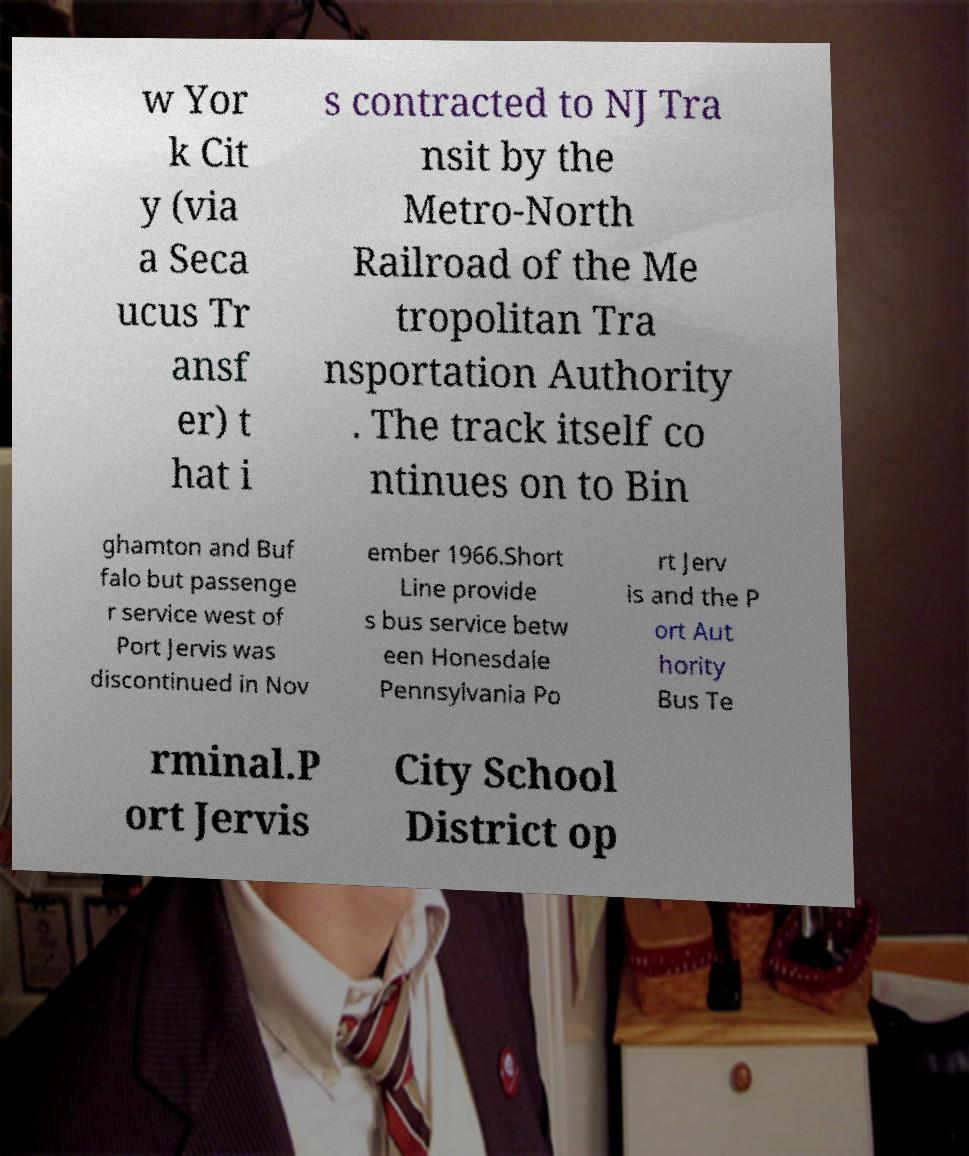Can you accurately transcribe the text from the provided image for me? w Yor k Cit y (via a Seca ucus Tr ansf er) t hat i s contracted to NJ Tra nsit by the Metro-North Railroad of the Me tropolitan Tra nsportation Authority . The track itself co ntinues on to Bin ghamton and Buf falo but passenge r service west of Port Jervis was discontinued in Nov ember 1966.Short Line provide s bus service betw een Honesdale Pennsylvania Po rt Jerv is and the P ort Aut hority Bus Te rminal.P ort Jervis City School District op 